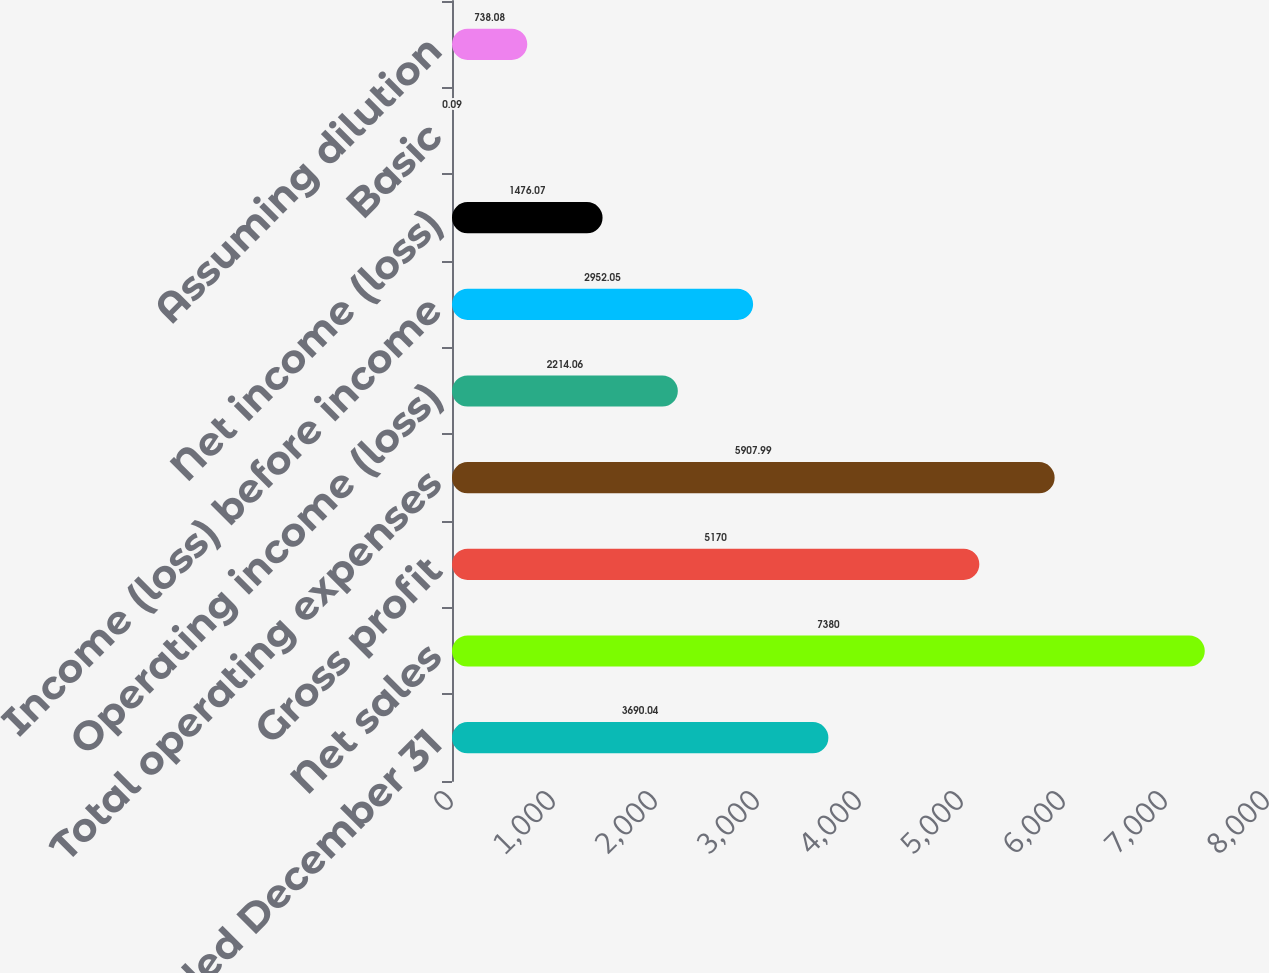Convert chart. <chart><loc_0><loc_0><loc_500><loc_500><bar_chart><fcel>Year Ended December 31<fcel>Net sales<fcel>Gross profit<fcel>Total operating expenses<fcel>Operating income (loss)<fcel>Income (loss) before income<fcel>Net income (loss)<fcel>Basic<fcel>Assuming dilution<nl><fcel>3690.04<fcel>7380<fcel>5170<fcel>5907.99<fcel>2214.06<fcel>2952.05<fcel>1476.07<fcel>0.09<fcel>738.08<nl></chart> 